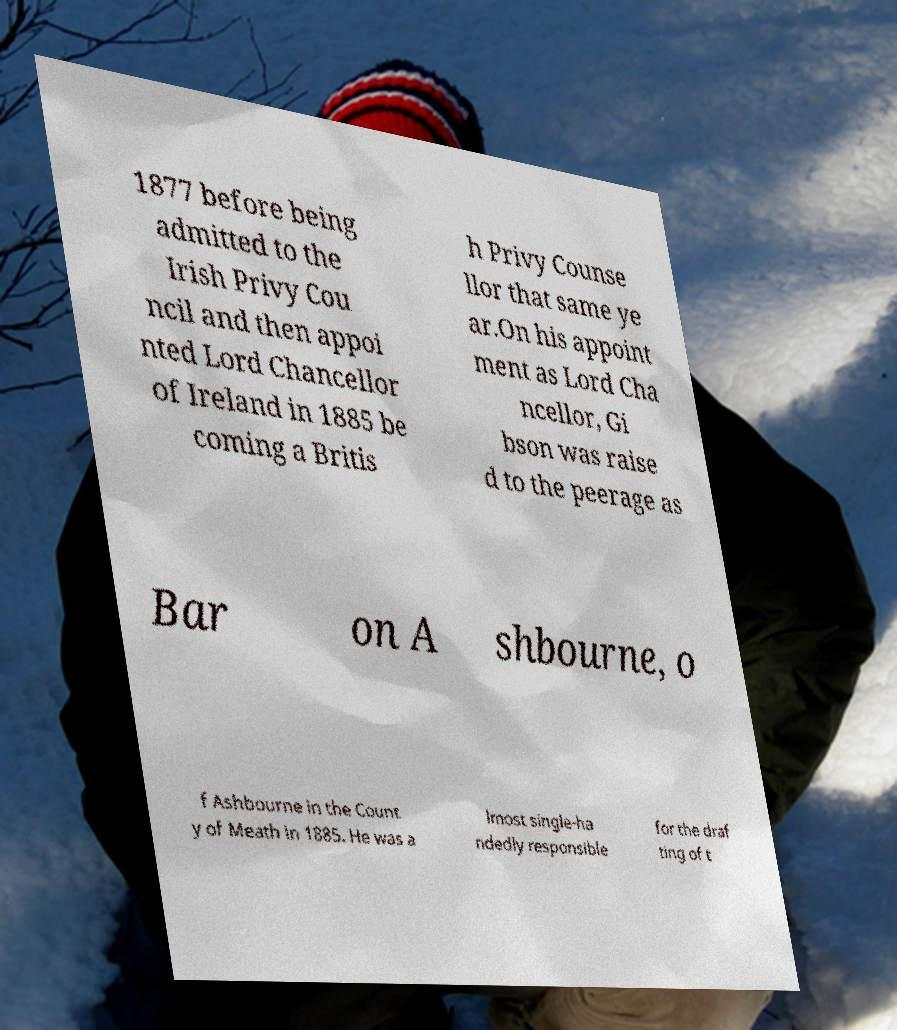For documentation purposes, I need the text within this image transcribed. Could you provide that? 1877 before being admitted to the Irish Privy Cou ncil and then appoi nted Lord Chancellor of Ireland in 1885 be coming a Britis h Privy Counse llor that same ye ar.On his appoint ment as Lord Cha ncellor, Gi bson was raise d to the peerage as Bar on A shbourne, o f Ashbourne in the Count y of Meath in 1885. He was a lmost single-ha ndedly responsible for the draf ting of t 